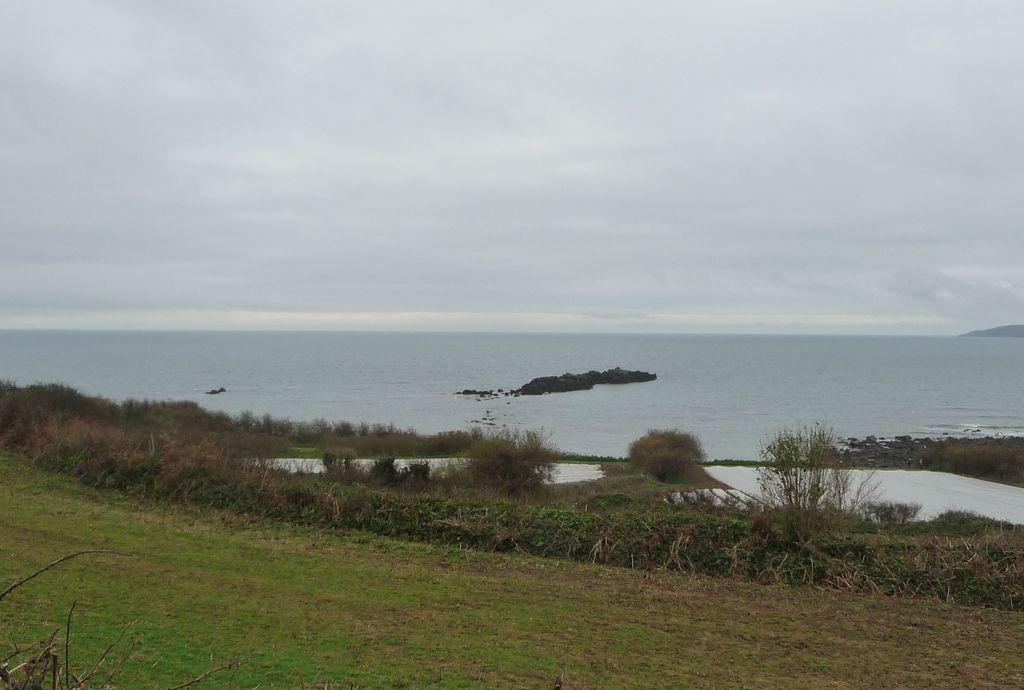What color is the grass in the image? The grass in the image is green. What can be seen in the background of the image? There is water visible in the background of the image. What is the color of the sky in the background of the image? The sky in the background of the image is white. What type of jam is being spread on the branch in the image? There is no jam or branch present in the image. How is the chain attached to the sky in the image? There is no chain present in the image. 